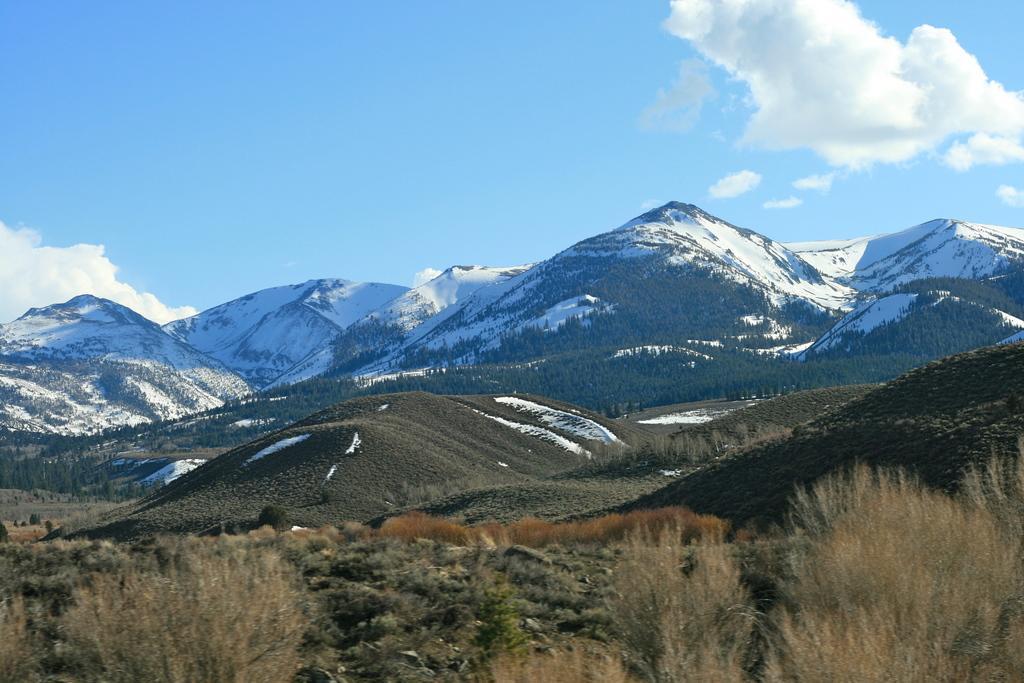Please provide a concise description of this image. In this image there are mountains. There are plants and trees on the mountains. In the background there is snow on the mountains. At the top there is the sky. 